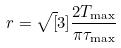<formula> <loc_0><loc_0><loc_500><loc_500>r = \sqrt { [ } 3 ] { \frac { 2 T _ { \max } } { \pi \tau _ { \max } } }</formula> 